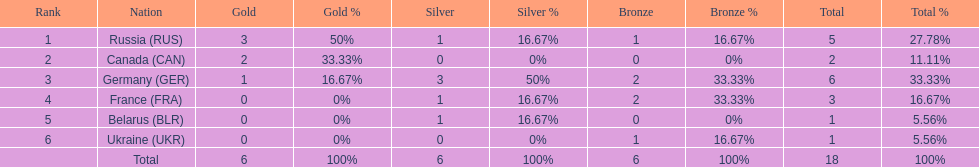Which country won the same amount of silver medals as the french and the russians? Belarus. 